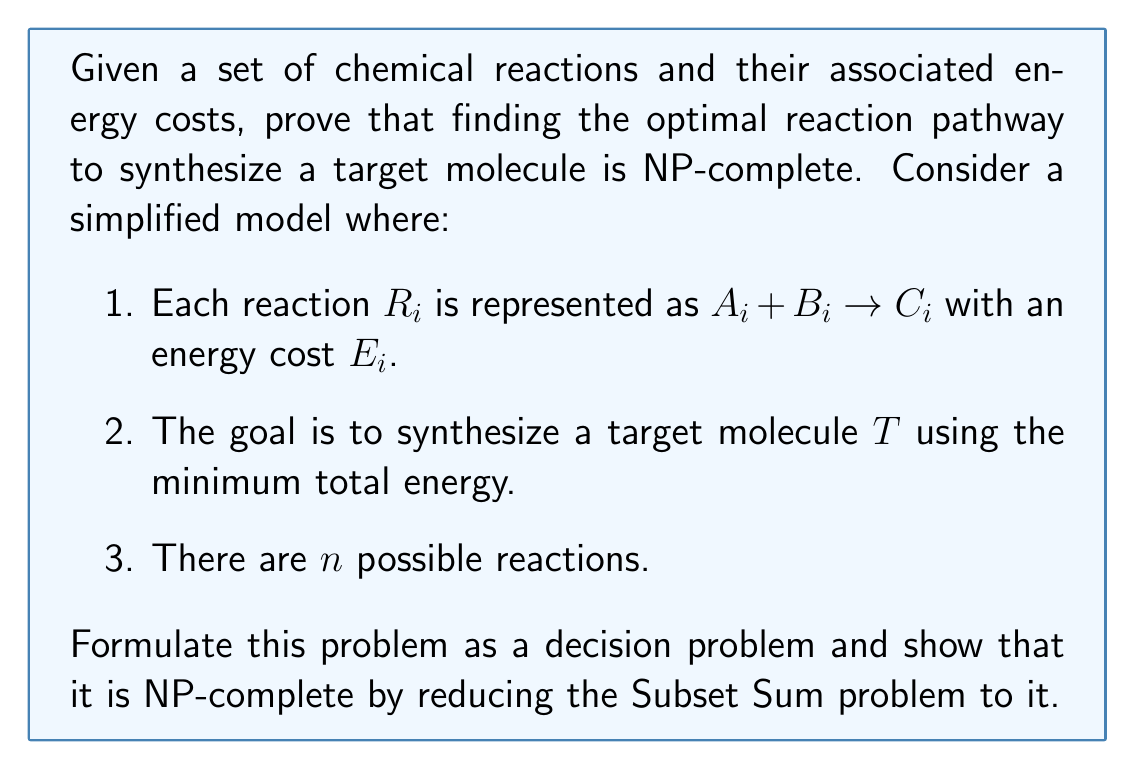Can you answer this question? To prove that optimizing chemical reaction pathways is NP-complete, we need to show that it's in NP and that it's NP-hard. We'll do this by reducing the Subset Sum problem to our Chemical Pathway Optimization (CPO) problem.

1. Formulating CPO as a decision problem:
   Given a set of reactions $R = \{R_1, R_2, ..., R_n\}$, their energy costs $E = \{E_1, E_2, ..., E_n\}$, a target molecule $T$, and a threshold energy $K$, decide if there exists a subset of reactions that synthesizes $T$ with total energy cost $\leq K$.

2. Showing CPO is in NP:
   A nondeterministic algorithm can guess a subset of reactions and verify in polynomial time if it synthesizes $T$ and if the total energy cost is $\leq K$.

3. Reducing Subset Sum to CPO:
   Subset Sum problem: Given a set of integers $S = \{s_1, s_2, ..., s_n\}$ and a target sum $W$, decide if there exists a subset of $S$ that sums to exactly $W$.

   Reduction:
   a) For each $s_i$ in $S$, create a reaction $R_i: A_i \rightarrow B$ with energy cost $E_i = s_i$.
   b) Create an additional reaction $R_{n+1}: B \rightarrow T$ with $E_{n+1} = 0$.
   c) Set the target molecule as $T$ and the threshold energy $K = W$.

4. Proving the reduction:
   - If Subset Sum has a solution, then CPO has a solution:
     The subset of $S$ that sums to $W$ corresponds to a set of reactions that produce $B$ with total energy cost $W$. Adding $R_{n+1}$ produces $T$ without additional cost.

   - If CPO has a solution, then Subset Sum has a solution:
     The subset of reactions (excluding $R_{n+1}$) that produces $T$ with total energy $\leq W$ corresponds to a subset of $S$ that sums to exactly $W$.

5. Complexity of the reduction:
   The reduction creates $n+1$ reactions and can be done in polynomial time.

Since we've shown that CPO is in NP and that a known NP-complete problem (Subset Sum) can be reduced to it in polynomial time, we conclude that CPO is NP-complete.
Answer: The Chemical Pathway Optimization (CPO) problem is NP-complete. 